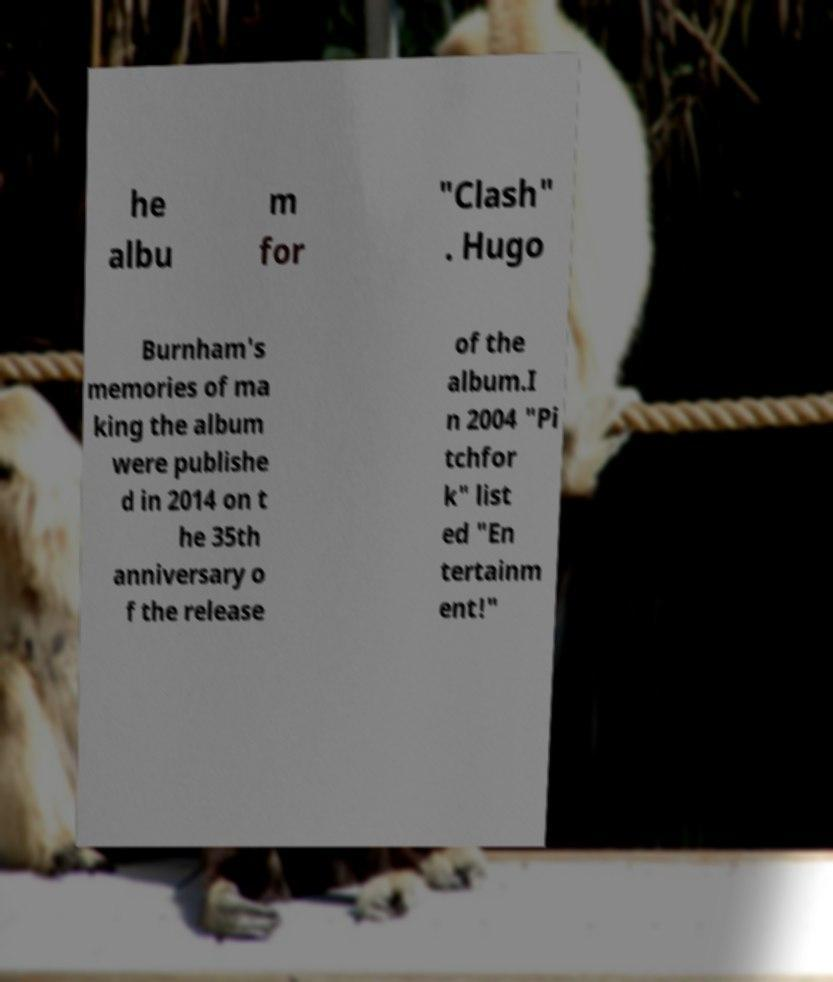I need the written content from this picture converted into text. Can you do that? he albu m for "Clash" . Hugo Burnham's memories of ma king the album were publishe d in 2014 on t he 35th anniversary o f the release of the album.I n 2004 "Pi tchfor k" list ed "En tertainm ent!" 